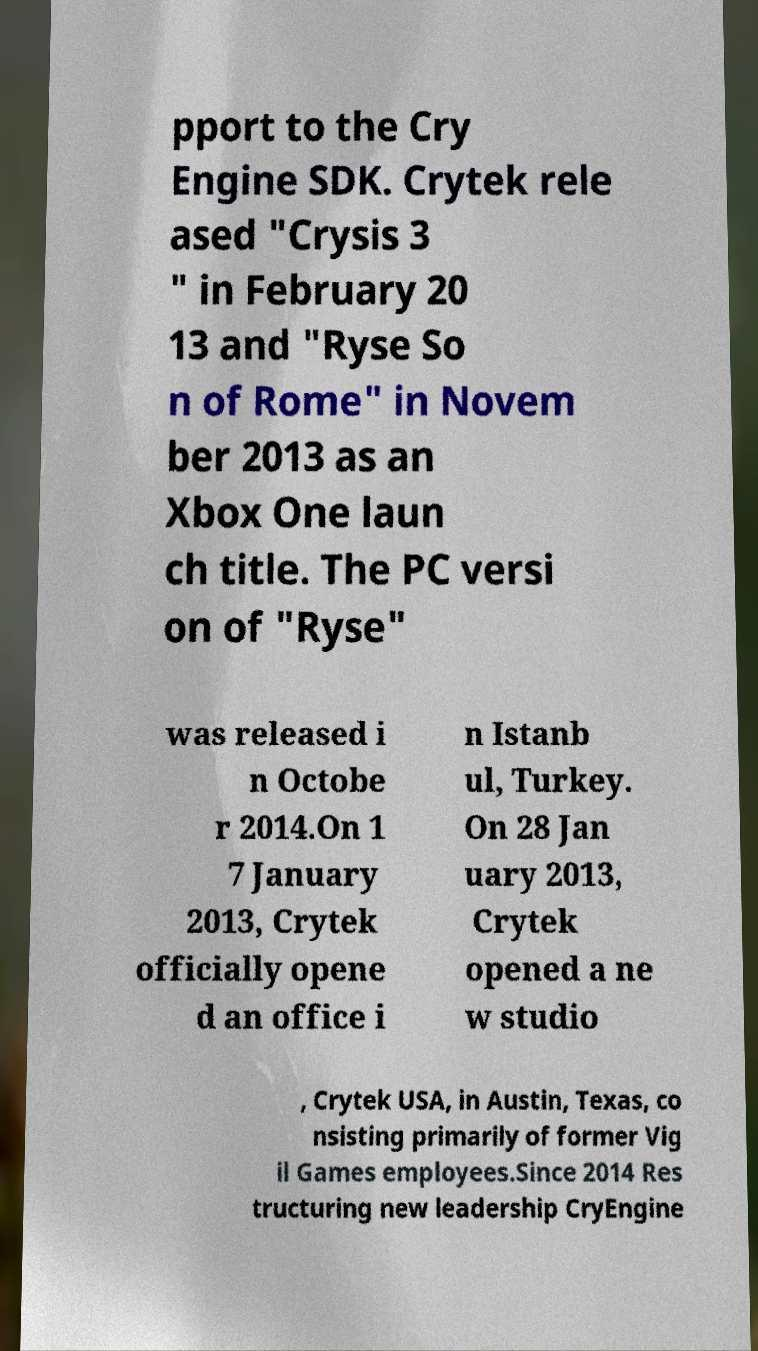Can you read and provide the text displayed in the image?This photo seems to have some interesting text. Can you extract and type it out for me? pport to the Cry Engine SDK. Crytek rele ased "Crysis 3 " in February 20 13 and "Ryse So n of Rome" in Novem ber 2013 as an Xbox One laun ch title. The PC versi on of "Ryse" was released i n Octobe r 2014.On 1 7 January 2013, Crytek officially opene d an office i n Istanb ul, Turkey. On 28 Jan uary 2013, Crytek opened a ne w studio , Crytek USA, in Austin, Texas, co nsisting primarily of former Vig il Games employees.Since 2014 Res tructuring new leadership CryEngine 